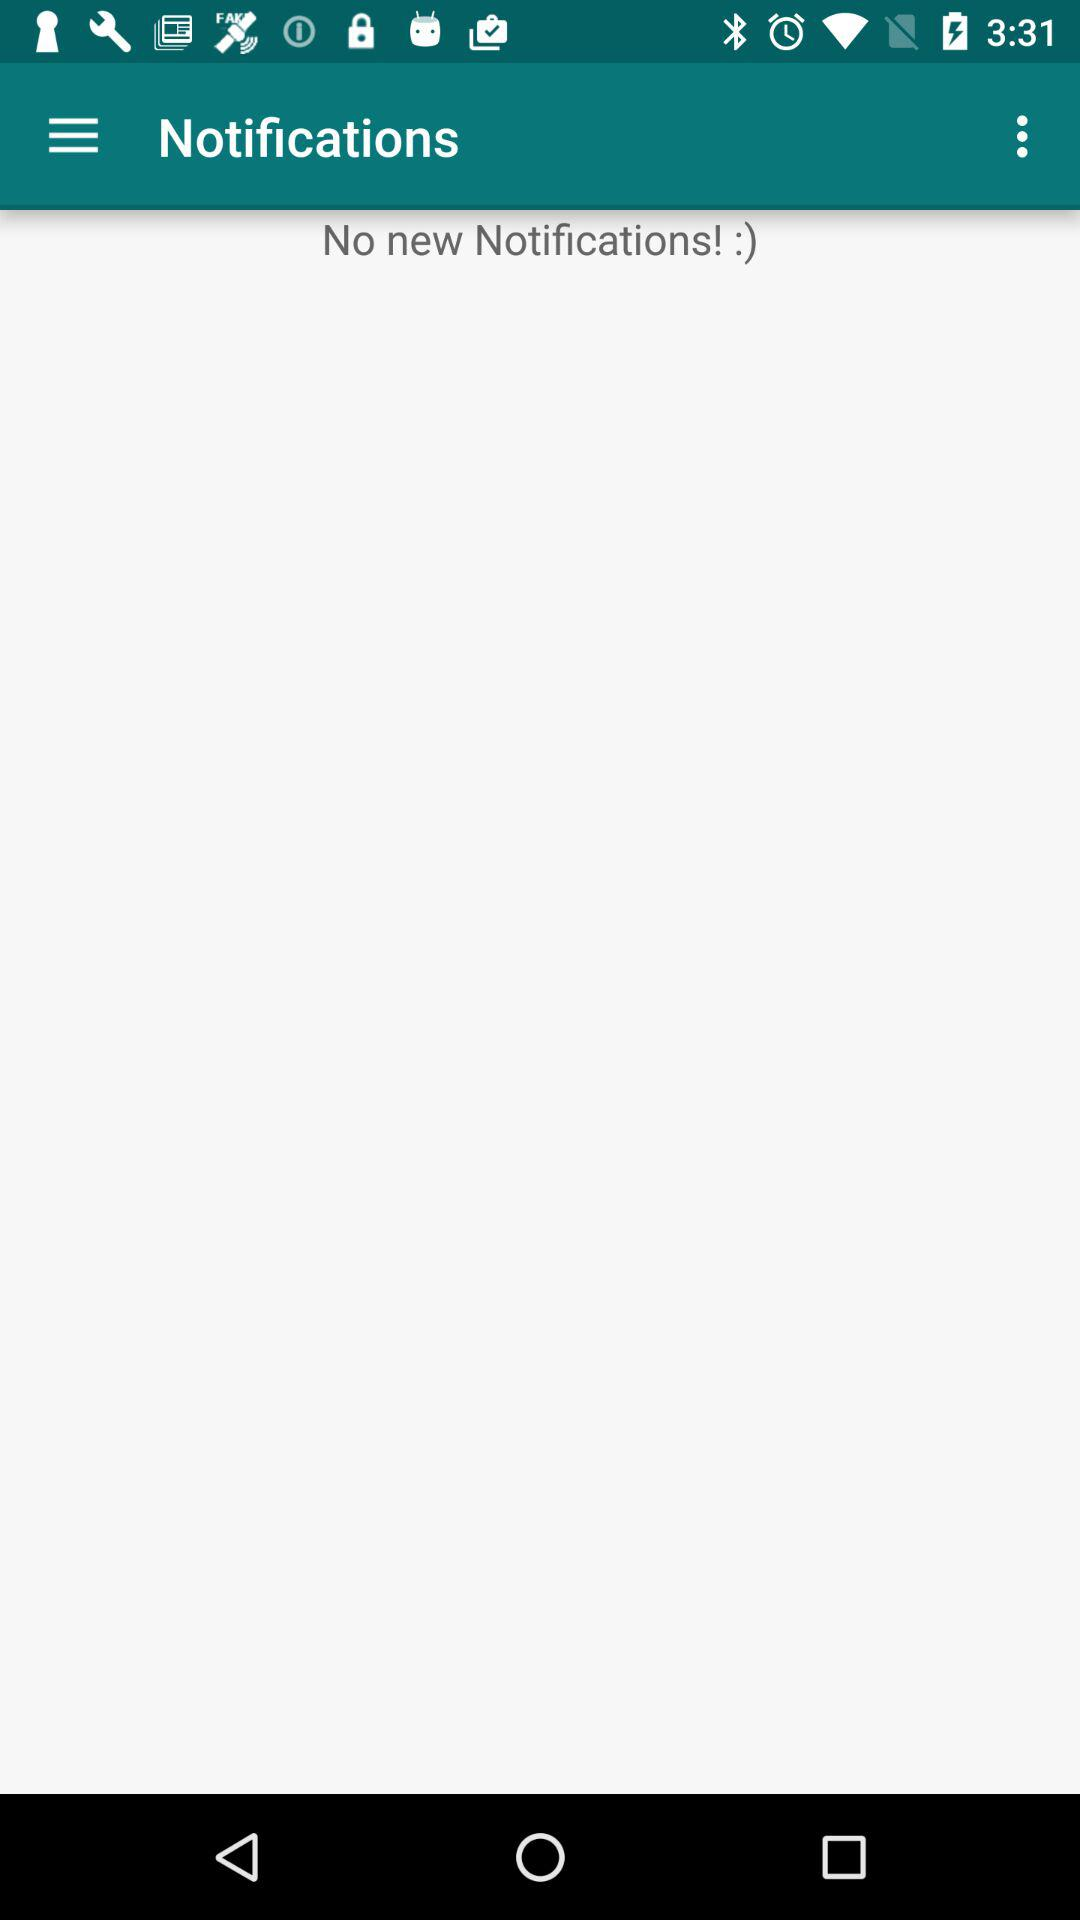Are there any new notifications? There are no new notifications. 